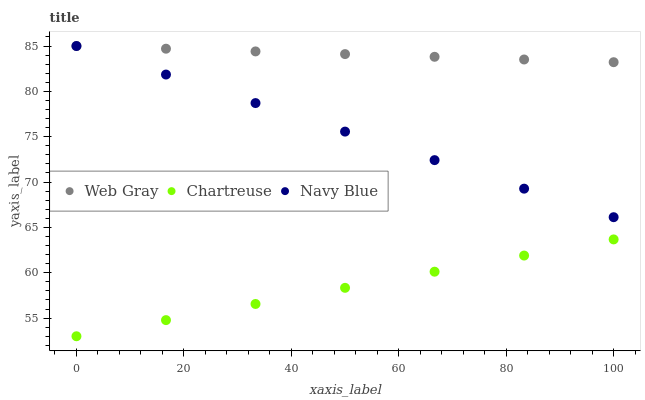Does Chartreuse have the minimum area under the curve?
Answer yes or no. Yes. Does Web Gray have the maximum area under the curve?
Answer yes or no. Yes. Does Web Gray have the minimum area under the curve?
Answer yes or no. No. Does Chartreuse have the maximum area under the curve?
Answer yes or no. No. Is Navy Blue the smoothest?
Answer yes or no. Yes. Is Web Gray the roughest?
Answer yes or no. Yes. Is Chartreuse the smoothest?
Answer yes or no. No. Is Chartreuse the roughest?
Answer yes or no. No. Does Chartreuse have the lowest value?
Answer yes or no. Yes. Does Web Gray have the lowest value?
Answer yes or no. No. Does Web Gray have the highest value?
Answer yes or no. Yes. Does Chartreuse have the highest value?
Answer yes or no. No. Is Chartreuse less than Web Gray?
Answer yes or no. Yes. Is Navy Blue greater than Chartreuse?
Answer yes or no. Yes. Does Navy Blue intersect Web Gray?
Answer yes or no. Yes. Is Navy Blue less than Web Gray?
Answer yes or no. No. Is Navy Blue greater than Web Gray?
Answer yes or no. No. Does Chartreuse intersect Web Gray?
Answer yes or no. No. 